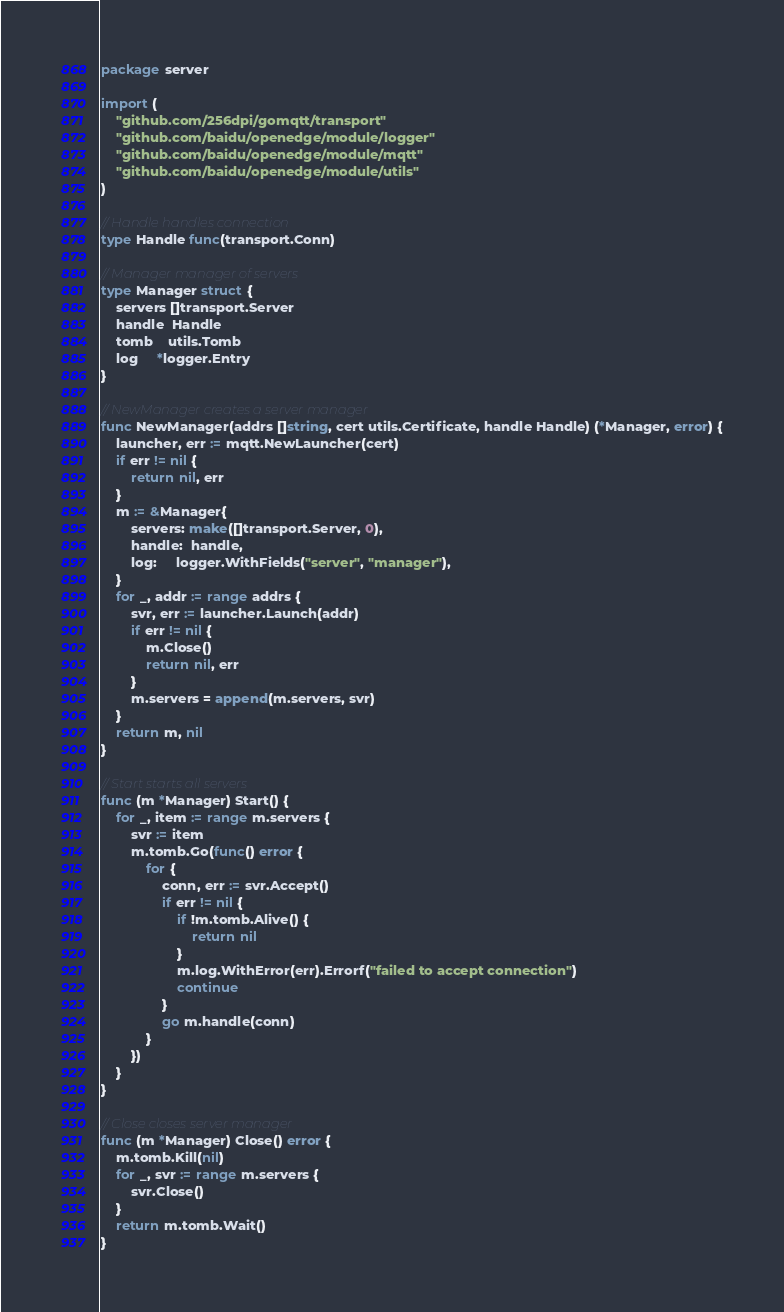Convert code to text. <code><loc_0><loc_0><loc_500><loc_500><_Go_>package server

import (
	"github.com/256dpi/gomqtt/transport"
	"github.com/baidu/openedge/module/logger"
	"github.com/baidu/openedge/module/mqtt"
	"github.com/baidu/openedge/module/utils"
)

// Handle handles connection
type Handle func(transport.Conn)

// Manager manager of servers
type Manager struct {
	servers []transport.Server
	handle  Handle
	tomb    utils.Tomb
	log     *logger.Entry
}

// NewManager creates a server manager
func NewManager(addrs []string, cert utils.Certificate, handle Handle) (*Manager, error) {
	launcher, err := mqtt.NewLauncher(cert)
	if err != nil {
		return nil, err
	}
	m := &Manager{
		servers: make([]transport.Server, 0),
		handle:  handle,
		log:     logger.WithFields("server", "manager"),
	}
	for _, addr := range addrs {
		svr, err := launcher.Launch(addr)
		if err != nil {
			m.Close()
			return nil, err
		}
		m.servers = append(m.servers, svr)
	}
	return m, nil
}

// Start starts all servers
func (m *Manager) Start() {
	for _, item := range m.servers {
		svr := item
		m.tomb.Go(func() error {
			for {
				conn, err := svr.Accept()
				if err != nil {
					if !m.tomb.Alive() {
						return nil
					}
					m.log.WithError(err).Errorf("failed to accept connection")
					continue
				}
				go m.handle(conn)
			}
		})
	}
}

// Close closes server manager
func (m *Manager) Close() error {
	m.tomb.Kill(nil)
	for _, svr := range m.servers {
		svr.Close()
	}
	return m.tomb.Wait()
}
</code> 